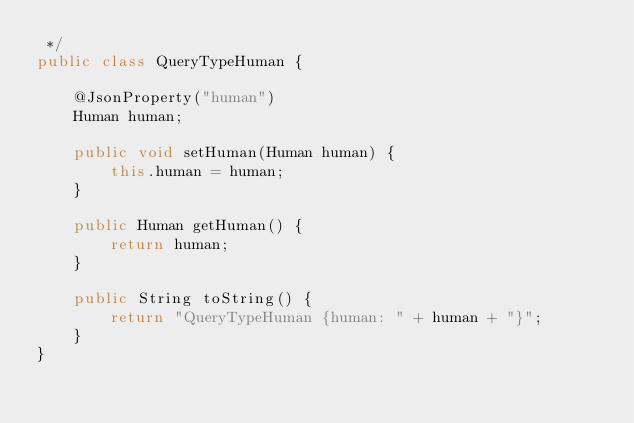Convert code to text. <code><loc_0><loc_0><loc_500><loc_500><_Java_> */
public class QueryTypeHuman {

	@JsonProperty("human")
	Human human;

	public void setHuman(Human human) {
		this.human = human;
	}

	public Human getHuman() {
		return human;
	}
	
    public String toString() {
        return "QueryTypeHuman {human: " + human + "}";
    }
}
</code> 